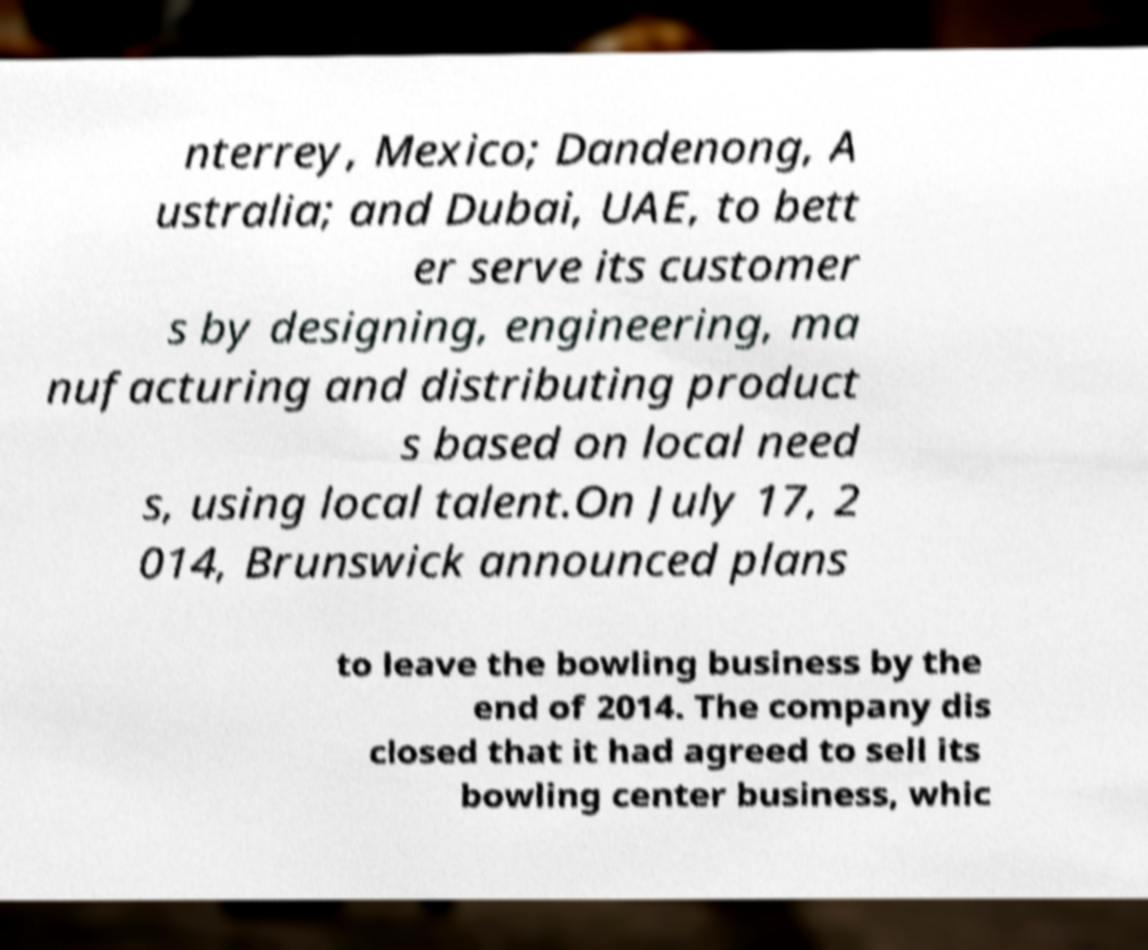What messages or text are displayed in this image? I need them in a readable, typed format. nterrey, Mexico; Dandenong, A ustralia; and Dubai, UAE, to bett er serve its customer s by designing, engineering, ma nufacturing and distributing product s based on local need s, using local talent.On July 17, 2 014, Brunswick announced plans to leave the bowling business by the end of 2014. The company dis closed that it had agreed to sell its bowling center business, whic 